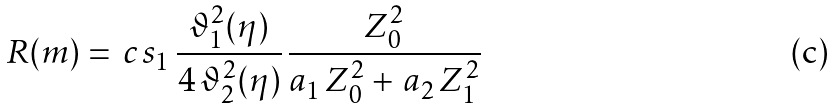Convert formula to latex. <formula><loc_0><loc_0><loc_500><loc_500>R ( m ) = \, c \, s _ { 1 } \, \frac { \vartheta ^ { 2 } _ { 1 } ( \eta ) } { 4 \, \vartheta ^ { 2 } _ { 2 } ( \eta ) } \, \frac { Z _ { 0 } ^ { 2 } } { a _ { 1 } \, Z _ { 0 } ^ { 2 } + \, a _ { 2 } \, Z _ { 1 } ^ { 2 } }</formula> 